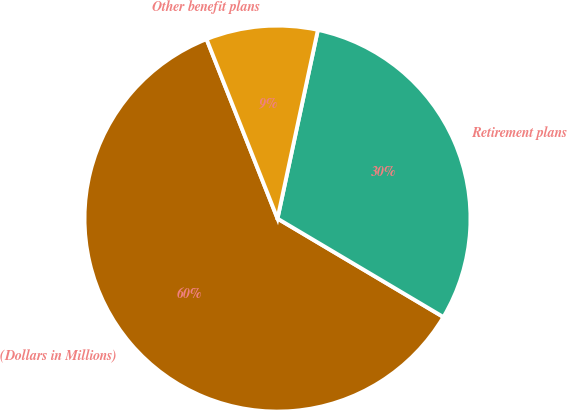Convert chart. <chart><loc_0><loc_0><loc_500><loc_500><pie_chart><fcel>(Dollars in Millions)<fcel>Retirement plans<fcel>Other benefit plans<nl><fcel>60.49%<fcel>30.17%<fcel>9.35%<nl></chart> 